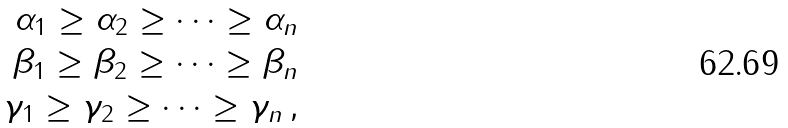<formula> <loc_0><loc_0><loc_500><loc_500>\alpha _ { 1 } \geq \alpha _ { 2 } \geq \cdots \geq \alpha _ { n } \\ \beta _ { 1 } \geq \beta _ { 2 } \geq \cdots \geq \beta _ { n } \\ \gamma _ { 1 } \geq \gamma _ { 2 } \geq \cdots \geq \gamma _ { n } \, ,</formula> 